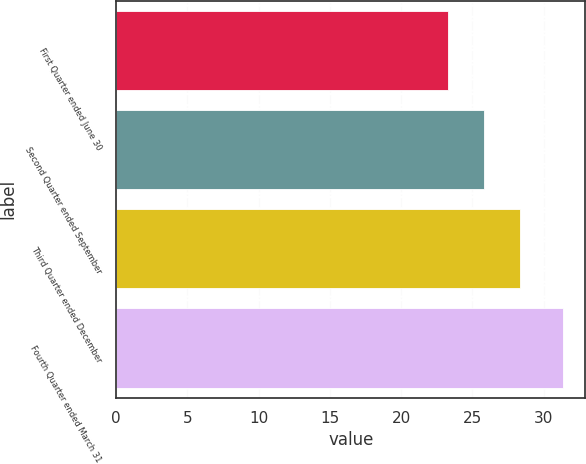<chart> <loc_0><loc_0><loc_500><loc_500><bar_chart><fcel>First Quarter ended June 30<fcel>Second Quarter ended September<fcel>Third Quarter ended December<fcel>Fourth Quarter ended March 31<nl><fcel>23.3<fcel>25.83<fcel>28.36<fcel>31.36<nl></chart> 